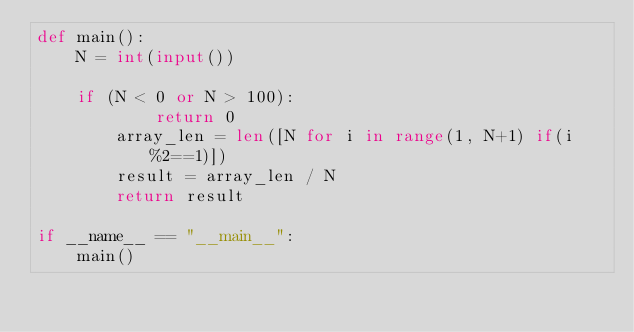Convert code to text. <code><loc_0><loc_0><loc_500><loc_500><_Python_>def main():
    N = int(input())
 
    if (N < 0 or N > 100):
            return 0
        array_len = len([N for i in range(1, N+1) if(i%2==1)])
        result = array_len / N
        return result
    
if __name__ == "__main__":
    main()</code> 